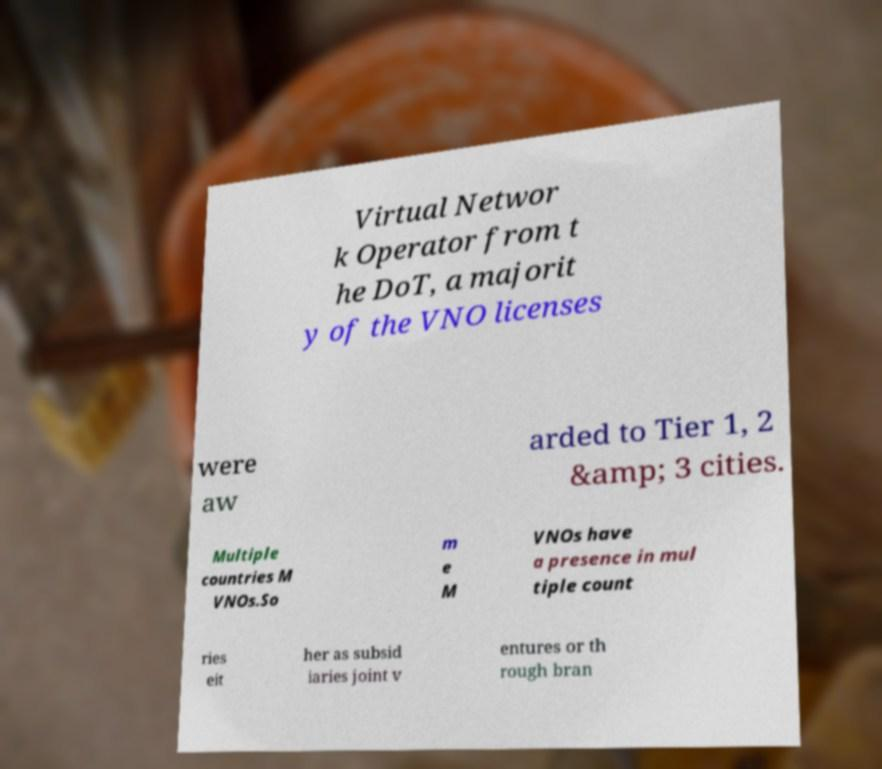There's text embedded in this image that I need extracted. Can you transcribe it verbatim? Virtual Networ k Operator from t he DoT, a majorit y of the VNO licenses were aw arded to Tier 1, 2 &amp; 3 cities. Multiple countries M VNOs.So m e M VNOs have a presence in mul tiple count ries eit her as subsid iaries joint v entures or th rough bran 